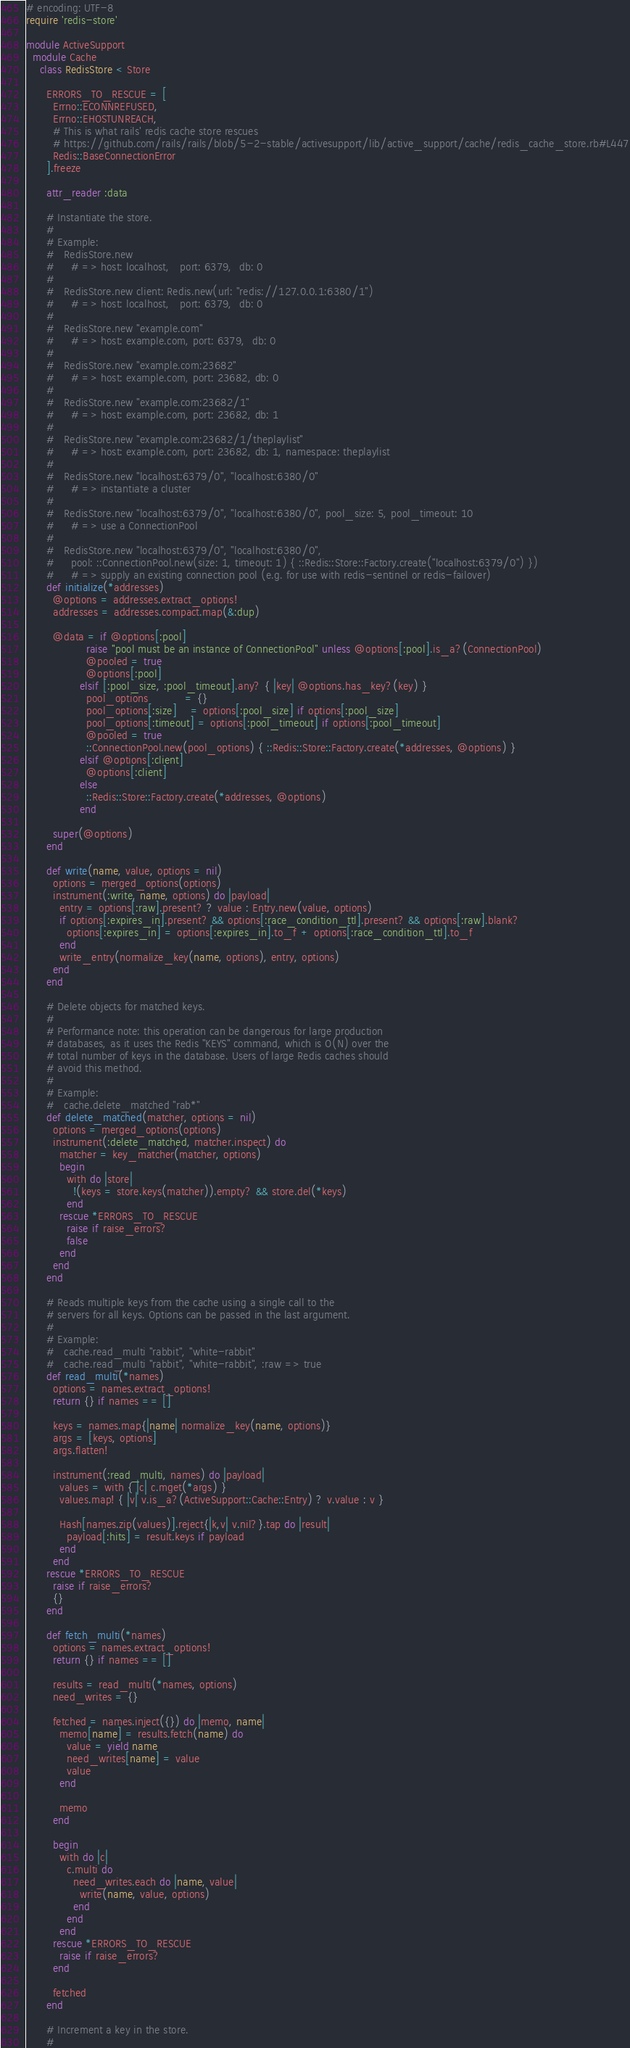Convert code to text. <code><loc_0><loc_0><loc_500><loc_500><_Ruby_># encoding: UTF-8
require 'redis-store'

module ActiveSupport
  module Cache
    class RedisStore < Store

      ERRORS_TO_RESCUE = [
        Errno::ECONNREFUSED,
        Errno::EHOSTUNREACH,
        # This is what rails' redis cache store rescues
        # https://github.com/rails/rails/blob/5-2-stable/activesupport/lib/active_support/cache/redis_cache_store.rb#L447
        Redis::BaseConnectionError
      ].freeze

      attr_reader :data

      # Instantiate the store.
      #
      # Example:
      #   RedisStore.new
      #     # => host: localhost,   port: 6379,  db: 0
      #
      #   RedisStore.new client: Redis.new(url: "redis://127.0.0.1:6380/1")
      #     # => host: localhost,   port: 6379,  db: 0
      #
      #   RedisStore.new "example.com"
      #     # => host: example.com, port: 6379,  db: 0
      #
      #   RedisStore.new "example.com:23682"
      #     # => host: example.com, port: 23682, db: 0
      #
      #   RedisStore.new "example.com:23682/1"
      #     # => host: example.com, port: 23682, db: 1
      #
      #   RedisStore.new "example.com:23682/1/theplaylist"
      #     # => host: example.com, port: 23682, db: 1, namespace: theplaylist
      #
      #   RedisStore.new "localhost:6379/0", "localhost:6380/0"
      #     # => instantiate a cluster
      #
      #   RedisStore.new "localhost:6379/0", "localhost:6380/0", pool_size: 5, pool_timeout: 10
      #     # => use a ConnectionPool
      #
      #   RedisStore.new "localhost:6379/0", "localhost:6380/0",
      #     pool: ::ConnectionPool.new(size: 1, timeout: 1) { ::Redis::Store::Factory.create("localhost:6379/0") })
      #     # => supply an existing connection pool (e.g. for use with redis-sentinel or redis-failover)
      def initialize(*addresses)
        @options = addresses.extract_options!
        addresses = addresses.compact.map(&:dup)

        @data = if @options[:pool]
                  raise "pool must be an instance of ConnectionPool" unless @options[:pool].is_a?(ConnectionPool)
                  @pooled = true
                  @options[:pool]
                elsif [:pool_size, :pool_timeout].any? { |key| @options.has_key?(key) }
                  pool_options           = {}
                  pool_options[:size]    = options[:pool_size] if options[:pool_size]
                  pool_options[:timeout] = options[:pool_timeout] if options[:pool_timeout]
                  @pooled = true
                  ::ConnectionPool.new(pool_options) { ::Redis::Store::Factory.create(*addresses, @options) }
                elsif @options[:client]
                  @options[:client]
                else
                  ::Redis::Store::Factory.create(*addresses, @options)
                end

        super(@options)
      end

      def write(name, value, options = nil)
        options = merged_options(options)
        instrument(:write, name, options) do |payload|
          entry = options[:raw].present? ? value : Entry.new(value, options)
          if options[:expires_in].present? && options[:race_condition_ttl].present? && options[:raw].blank?
            options[:expires_in] = options[:expires_in].to_f + options[:race_condition_ttl].to_f
          end
          write_entry(normalize_key(name, options), entry, options)
        end
      end

      # Delete objects for matched keys.
      #
      # Performance note: this operation can be dangerous for large production
      # databases, as it uses the Redis "KEYS" command, which is O(N) over the
      # total number of keys in the database. Users of large Redis caches should
      # avoid this method.
      #
      # Example:
      #   cache.delete_matched "rab*"
      def delete_matched(matcher, options = nil)
        options = merged_options(options)
        instrument(:delete_matched, matcher.inspect) do
          matcher = key_matcher(matcher, options)
          begin
            with do |store|
              !(keys = store.keys(matcher)).empty? && store.del(*keys)
            end
          rescue *ERRORS_TO_RESCUE
            raise if raise_errors?
            false
          end
        end
      end

      # Reads multiple keys from the cache using a single call to the
      # servers for all keys. Options can be passed in the last argument.
      #
      # Example:
      #   cache.read_multi "rabbit", "white-rabbit"
      #   cache.read_multi "rabbit", "white-rabbit", :raw => true
      def read_multi(*names)
        options = names.extract_options!
        return {} if names == []

        keys = names.map{|name| normalize_key(name, options)}
        args = [keys, options]
        args.flatten!

        instrument(:read_multi, names) do |payload|
          values = with { |c| c.mget(*args) }
          values.map! { |v| v.is_a?(ActiveSupport::Cache::Entry) ? v.value : v }

          Hash[names.zip(values)].reject{|k,v| v.nil?}.tap do |result|
            payload[:hits] = result.keys if payload
          end
        end
      rescue *ERRORS_TO_RESCUE
        raise if raise_errors?
        {}
      end

      def fetch_multi(*names)
        options = names.extract_options!
        return {} if names == []

        results = read_multi(*names, options)
        need_writes = {}

        fetched = names.inject({}) do |memo, name|
          memo[name] = results.fetch(name) do
            value = yield name
            need_writes[name] = value
            value
          end

          memo
        end

        begin
          with do |c|
            c.multi do
              need_writes.each do |name, value|
                write(name, value, options)
              end
            end
          end
        rescue *ERRORS_TO_RESCUE
          raise if raise_errors?
        end

        fetched
      end

      # Increment a key in the store.
      #</code> 